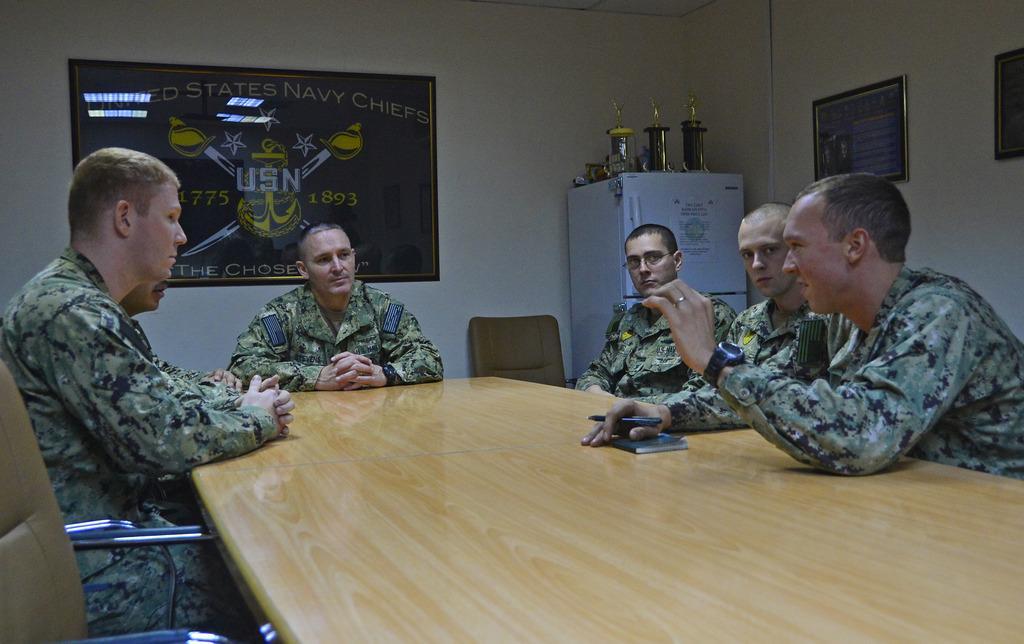Can you describe this image briefly? In the foreground of this image, there are men sitting on the chairs around the table on which there is a book and a man is holding a pen. In the background, there are frames on the wall, a refrigerator on which there are awards and few objects. Beside it, there is a chair. 